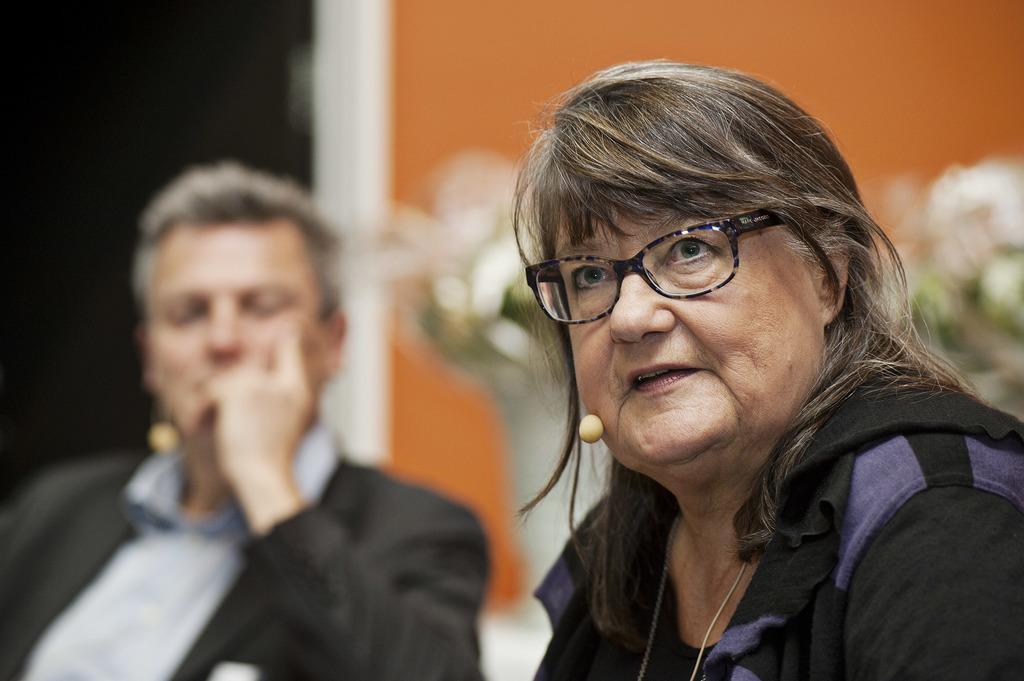How would you summarize this image in a sentence or two? In this image we can see a woman wearing spectacles and behind her we can see a man in a black and white dress. 